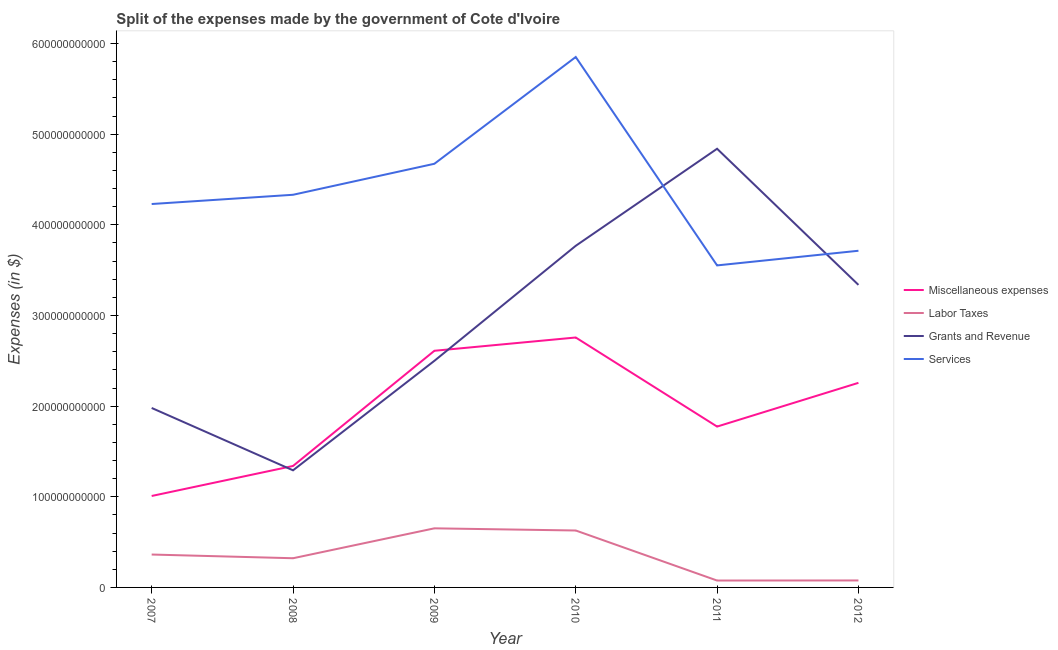How many different coloured lines are there?
Offer a very short reply. 4. Does the line corresponding to amount spent on labor taxes intersect with the line corresponding to amount spent on miscellaneous expenses?
Make the answer very short. No. Is the number of lines equal to the number of legend labels?
Offer a very short reply. Yes. What is the amount spent on miscellaneous expenses in 2011?
Give a very brief answer. 1.77e+11. Across all years, what is the maximum amount spent on labor taxes?
Ensure brevity in your answer.  6.52e+1. Across all years, what is the minimum amount spent on grants and revenue?
Offer a terse response. 1.29e+11. What is the total amount spent on services in the graph?
Provide a succinct answer. 2.64e+12. What is the difference between the amount spent on services in 2011 and that in 2012?
Keep it short and to the point. -1.62e+1. What is the difference between the amount spent on grants and revenue in 2011 and the amount spent on services in 2008?
Give a very brief answer. 5.08e+1. What is the average amount spent on miscellaneous expenses per year?
Your answer should be very brief. 1.96e+11. In the year 2009, what is the difference between the amount spent on services and amount spent on miscellaneous expenses?
Your answer should be compact. 2.06e+11. What is the ratio of the amount spent on labor taxes in 2007 to that in 2010?
Provide a short and direct response. 0.58. What is the difference between the highest and the second highest amount spent on grants and revenue?
Offer a very short reply. 1.07e+11. What is the difference between the highest and the lowest amount spent on labor taxes?
Your response must be concise. 5.76e+1. In how many years, is the amount spent on miscellaneous expenses greater than the average amount spent on miscellaneous expenses taken over all years?
Provide a short and direct response. 3. Is the sum of the amount spent on labor taxes in 2008 and 2010 greater than the maximum amount spent on miscellaneous expenses across all years?
Your answer should be compact. No. Does the amount spent on grants and revenue monotonically increase over the years?
Provide a short and direct response. No. Is the amount spent on grants and revenue strictly greater than the amount spent on labor taxes over the years?
Offer a very short reply. Yes. Is the amount spent on labor taxes strictly less than the amount spent on services over the years?
Give a very brief answer. Yes. How many years are there in the graph?
Your answer should be very brief. 6. What is the difference between two consecutive major ticks on the Y-axis?
Your response must be concise. 1.00e+11. Does the graph contain any zero values?
Your response must be concise. No. Does the graph contain grids?
Make the answer very short. No. How are the legend labels stacked?
Your answer should be very brief. Vertical. What is the title of the graph?
Give a very brief answer. Split of the expenses made by the government of Cote d'Ivoire. Does "Permanent crop land" appear as one of the legend labels in the graph?
Your answer should be compact. No. What is the label or title of the Y-axis?
Make the answer very short. Expenses (in $). What is the Expenses (in $) of Miscellaneous expenses in 2007?
Your answer should be very brief. 1.01e+11. What is the Expenses (in $) in Labor Taxes in 2007?
Your answer should be very brief. 3.63e+1. What is the Expenses (in $) in Grants and Revenue in 2007?
Provide a short and direct response. 1.98e+11. What is the Expenses (in $) of Services in 2007?
Provide a succinct answer. 4.23e+11. What is the Expenses (in $) in Miscellaneous expenses in 2008?
Provide a succinct answer. 1.34e+11. What is the Expenses (in $) of Labor Taxes in 2008?
Ensure brevity in your answer.  3.22e+1. What is the Expenses (in $) in Grants and Revenue in 2008?
Make the answer very short. 1.29e+11. What is the Expenses (in $) in Services in 2008?
Give a very brief answer. 4.33e+11. What is the Expenses (in $) of Miscellaneous expenses in 2009?
Your answer should be compact. 2.61e+11. What is the Expenses (in $) of Labor Taxes in 2009?
Give a very brief answer. 6.52e+1. What is the Expenses (in $) in Grants and Revenue in 2009?
Keep it short and to the point. 2.50e+11. What is the Expenses (in $) of Services in 2009?
Your answer should be very brief. 4.67e+11. What is the Expenses (in $) of Miscellaneous expenses in 2010?
Offer a very short reply. 2.76e+11. What is the Expenses (in $) in Labor Taxes in 2010?
Offer a very short reply. 6.28e+1. What is the Expenses (in $) in Grants and Revenue in 2010?
Offer a very short reply. 3.77e+11. What is the Expenses (in $) in Services in 2010?
Offer a very short reply. 5.85e+11. What is the Expenses (in $) in Miscellaneous expenses in 2011?
Your answer should be compact. 1.77e+11. What is the Expenses (in $) in Labor Taxes in 2011?
Your response must be concise. 7.60e+09. What is the Expenses (in $) of Grants and Revenue in 2011?
Give a very brief answer. 4.84e+11. What is the Expenses (in $) in Services in 2011?
Provide a short and direct response. 3.55e+11. What is the Expenses (in $) of Miscellaneous expenses in 2012?
Give a very brief answer. 2.26e+11. What is the Expenses (in $) in Labor Taxes in 2012?
Provide a short and direct response. 7.70e+09. What is the Expenses (in $) in Grants and Revenue in 2012?
Provide a succinct answer. 3.34e+11. What is the Expenses (in $) of Services in 2012?
Your response must be concise. 3.71e+11. Across all years, what is the maximum Expenses (in $) of Miscellaneous expenses?
Ensure brevity in your answer.  2.76e+11. Across all years, what is the maximum Expenses (in $) in Labor Taxes?
Provide a succinct answer. 6.52e+1. Across all years, what is the maximum Expenses (in $) in Grants and Revenue?
Provide a succinct answer. 4.84e+11. Across all years, what is the maximum Expenses (in $) in Services?
Make the answer very short. 5.85e+11. Across all years, what is the minimum Expenses (in $) of Miscellaneous expenses?
Offer a terse response. 1.01e+11. Across all years, what is the minimum Expenses (in $) in Labor Taxes?
Give a very brief answer. 7.60e+09. Across all years, what is the minimum Expenses (in $) in Grants and Revenue?
Make the answer very short. 1.29e+11. Across all years, what is the minimum Expenses (in $) of Services?
Offer a very short reply. 3.55e+11. What is the total Expenses (in $) of Miscellaneous expenses in the graph?
Your answer should be compact. 1.17e+12. What is the total Expenses (in $) of Labor Taxes in the graph?
Ensure brevity in your answer.  2.12e+11. What is the total Expenses (in $) in Grants and Revenue in the graph?
Provide a succinct answer. 1.77e+12. What is the total Expenses (in $) in Services in the graph?
Your response must be concise. 2.64e+12. What is the difference between the Expenses (in $) in Miscellaneous expenses in 2007 and that in 2008?
Provide a short and direct response. -3.31e+1. What is the difference between the Expenses (in $) of Labor Taxes in 2007 and that in 2008?
Provide a short and direct response. 4.10e+09. What is the difference between the Expenses (in $) of Grants and Revenue in 2007 and that in 2008?
Provide a short and direct response. 6.88e+1. What is the difference between the Expenses (in $) of Services in 2007 and that in 2008?
Provide a succinct answer. -1.02e+1. What is the difference between the Expenses (in $) in Miscellaneous expenses in 2007 and that in 2009?
Offer a very short reply. -1.60e+11. What is the difference between the Expenses (in $) in Labor Taxes in 2007 and that in 2009?
Offer a very short reply. -2.89e+1. What is the difference between the Expenses (in $) of Grants and Revenue in 2007 and that in 2009?
Give a very brief answer. -5.20e+1. What is the difference between the Expenses (in $) of Services in 2007 and that in 2009?
Offer a terse response. -4.44e+1. What is the difference between the Expenses (in $) of Miscellaneous expenses in 2007 and that in 2010?
Offer a terse response. -1.75e+11. What is the difference between the Expenses (in $) in Labor Taxes in 2007 and that in 2010?
Offer a terse response. -2.65e+1. What is the difference between the Expenses (in $) of Grants and Revenue in 2007 and that in 2010?
Make the answer very short. -1.79e+11. What is the difference between the Expenses (in $) of Services in 2007 and that in 2010?
Your answer should be compact. -1.62e+11. What is the difference between the Expenses (in $) of Miscellaneous expenses in 2007 and that in 2011?
Your response must be concise. -7.66e+1. What is the difference between the Expenses (in $) in Labor Taxes in 2007 and that in 2011?
Provide a short and direct response. 2.87e+1. What is the difference between the Expenses (in $) of Grants and Revenue in 2007 and that in 2011?
Offer a very short reply. -2.86e+11. What is the difference between the Expenses (in $) of Services in 2007 and that in 2011?
Make the answer very short. 6.77e+1. What is the difference between the Expenses (in $) in Miscellaneous expenses in 2007 and that in 2012?
Ensure brevity in your answer.  -1.25e+11. What is the difference between the Expenses (in $) in Labor Taxes in 2007 and that in 2012?
Give a very brief answer. 2.86e+1. What is the difference between the Expenses (in $) in Grants and Revenue in 2007 and that in 2012?
Your response must be concise. -1.36e+11. What is the difference between the Expenses (in $) in Services in 2007 and that in 2012?
Your response must be concise. 5.16e+1. What is the difference between the Expenses (in $) of Miscellaneous expenses in 2008 and that in 2009?
Keep it short and to the point. -1.27e+11. What is the difference between the Expenses (in $) in Labor Taxes in 2008 and that in 2009?
Offer a very short reply. -3.30e+1. What is the difference between the Expenses (in $) of Grants and Revenue in 2008 and that in 2009?
Give a very brief answer. -1.21e+11. What is the difference between the Expenses (in $) of Services in 2008 and that in 2009?
Your response must be concise. -3.42e+1. What is the difference between the Expenses (in $) of Miscellaneous expenses in 2008 and that in 2010?
Your answer should be very brief. -1.42e+11. What is the difference between the Expenses (in $) of Labor Taxes in 2008 and that in 2010?
Keep it short and to the point. -3.06e+1. What is the difference between the Expenses (in $) in Grants and Revenue in 2008 and that in 2010?
Ensure brevity in your answer.  -2.48e+11. What is the difference between the Expenses (in $) in Services in 2008 and that in 2010?
Your response must be concise. -1.52e+11. What is the difference between the Expenses (in $) in Miscellaneous expenses in 2008 and that in 2011?
Provide a short and direct response. -4.35e+1. What is the difference between the Expenses (in $) of Labor Taxes in 2008 and that in 2011?
Provide a succinct answer. 2.46e+1. What is the difference between the Expenses (in $) of Grants and Revenue in 2008 and that in 2011?
Keep it short and to the point. -3.55e+11. What is the difference between the Expenses (in $) of Services in 2008 and that in 2011?
Offer a terse response. 7.79e+1. What is the difference between the Expenses (in $) in Miscellaneous expenses in 2008 and that in 2012?
Provide a short and direct response. -9.17e+1. What is the difference between the Expenses (in $) of Labor Taxes in 2008 and that in 2012?
Your answer should be very brief. 2.45e+1. What is the difference between the Expenses (in $) of Grants and Revenue in 2008 and that in 2012?
Ensure brevity in your answer.  -2.05e+11. What is the difference between the Expenses (in $) in Services in 2008 and that in 2012?
Make the answer very short. 6.18e+1. What is the difference between the Expenses (in $) in Miscellaneous expenses in 2009 and that in 2010?
Give a very brief answer. -1.47e+1. What is the difference between the Expenses (in $) in Labor Taxes in 2009 and that in 2010?
Make the answer very short. 2.39e+09. What is the difference between the Expenses (in $) of Grants and Revenue in 2009 and that in 2010?
Offer a terse response. -1.27e+11. What is the difference between the Expenses (in $) of Services in 2009 and that in 2010?
Offer a very short reply. -1.18e+11. What is the difference between the Expenses (in $) in Miscellaneous expenses in 2009 and that in 2011?
Offer a terse response. 8.36e+1. What is the difference between the Expenses (in $) of Labor Taxes in 2009 and that in 2011?
Your answer should be compact. 5.76e+1. What is the difference between the Expenses (in $) in Grants and Revenue in 2009 and that in 2011?
Make the answer very short. -2.34e+11. What is the difference between the Expenses (in $) of Services in 2009 and that in 2011?
Give a very brief answer. 1.12e+11. What is the difference between the Expenses (in $) in Miscellaneous expenses in 2009 and that in 2012?
Ensure brevity in your answer.  3.54e+1. What is the difference between the Expenses (in $) of Labor Taxes in 2009 and that in 2012?
Your answer should be very brief. 5.75e+1. What is the difference between the Expenses (in $) in Grants and Revenue in 2009 and that in 2012?
Your answer should be very brief. -8.38e+1. What is the difference between the Expenses (in $) of Services in 2009 and that in 2012?
Make the answer very short. 9.60e+1. What is the difference between the Expenses (in $) in Miscellaneous expenses in 2010 and that in 2011?
Your answer should be compact. 9.83e+1. What is the difference between the Expenses (in $) in Labor Taxes in 2010 and that in 2011?
Your answer should be very brief. 5.52e+1. What is the difference between the Expenses (in $) of Grants and Revenue in 2010 and that in 2011?
Your answer should be very brief. -1.07e+11. What is the difference between the Expenses (in $) in Services in 2010 and that in 2011?
Offer a very short reply. 2.30e+11. What is the difference between the Expenses (in $) in Miscellaneous expenses in 2010 and that in 2012?
Your answer should be very brief. 5.00e+1. What is the difference between the Expenses (in $) of Labor Taxes in 2010 and that in 2012?
Provide a succinct answer. 5.51e+1. What is the difference between the Expenses (in $) in Grants and Revenue in 2010 and that in 2012?
Your answer should be very brief. 4.31e+1. What is the difference between the Expenses (in $) of Services in 2010 and that in 2012?
Your response must be concise. 2.14e+11. What is the difference between the Expenses (in $) of Miscellaneous expenses in 2011 and that in 2012?
Give a very brief answer. -4.83e+1. What is the difference between the Expenses (in $) of Labor Taxes in 2011 and that in 2012?
Your answer should be very brief. -1.00e+08. What is the difference between the Expenses (in $) of Grants and Revenue in 2011 and that in 2012?
Give a very brief answer. 1.50e+11. What is the difference between the Expenses (in $) in Services in 2011 and that in 2012?
Your answer should be compact. -1.62e+1. What is the difference between the Expenses (in $) in Miscellaneous expenses in 2007 and the Expenses (in $) in Labor Taxes in 2008?
Your answer should be compact. 6.87e+1. What is the difference between the Expenses (in $) in Miscellaneous expenses in 2007 and the Expenses (in $) in Grants and Revenue in 2008?
Give a very brief answer. -2.83e+1. What is the difference between the Expenses (in $) of Miscellaneous expenses in 2007 and the Expenses (in $) of Services in 2008?
Provide a succinct answer. -3.32e+11. What is the difference between the Expenses (in $) in Labor Taxes in 2007 and the Expenses (in $) in Grants and Revenue in 2008?
Offer a terse response. -9.29e+1. What is the difference between the Expenses (in $) in Labor Taxes in 2007 and the Expenses (in $) in Services in 2008?
Offer a very short reply. -3.97e+11. What is the difference between the Expenses (in $) of Grants and Revenue in 2007 and the Expenses (in $) of Services in 2008?
Your answer should be compact. -2.35e+11. What is the difference between the Expenses (in $) of Miscellaneous expenses in 2007 and the Expenses (in $) of Labor Taxes in 2009?
Your response must be concise. 3.57e+1. What is the difference between the Expenses (in $) of Miscellaneous expenses in 2007 and the Expenses (in $) of Grants and Revenue in 2009?
Your response must be concise. -1.49e+11. What is the difference between the Expenses (in $) of Miscellaneous expenses in 2007 and the Expenses (in $) of Services in 2009?
Provide a short and direct response. -3.66e+11. What is the difference between the Expenses (in $) of Labor Taxes in 2007 and the Expenses (in $) of Grants and Revenue in 2009?
Your answer should be very brief. -2.14e+11. What is the difference between the Expenses (in $) in Labor Taxes in 2007 and the Expenses (in $) in Services in 2009?
Give a very brief answer. -4.31e+11. What is the difference between the Expenses (in $) of Grants and Revenue in 2007 and the Expenses (in $) of Services in 2009?
Your answer should be very brief. -2.69e+11. What is the difference between the Expenses (in $) of Miscellaneous expenses in 2007 and the Expenses (in $) of Labor Taxes in 2010?
Provide a succinct answer. 3.81e+1. What is the difference between the Expenses (in $) of Miscellaneous expenses in 2007 and the Expenses (in $) of Grants and Revenue in 2010?
Your answer should be compact. -2.76e+11. What is the difference between the Expenses (in $) in Miscellaneous expenses in 2007 and the Expenses (in $) in Services in 2010?
Provide a succinct answer. -4.84e+11. What is the difference between the Expenses (in $) in Labor Taxes in 2007 and the Expenses (in $) in Grants and Revenue in 2010?
Your response must be concise. -3.41e+11. What is the difference between the Expenses (in $) in Labor Taxes in 2007 and the Expenses (in $) in Services in 2010?
Provide a succinct answer. -5.49e+11. What is the difference between the Expenses (in $) of Grants and Revenue in 2007 and the Expenses (in $) of Services in 2010?
Make the answer very short. -3.87e+11. What is the difference between the Expenses (in $) in Miscellaneous expenses in 2007 and the Expenses (in $) in Labor Taxes in 2011?
Ensure brevity in your answer.  9.33e+1. What is the difference between the Expenses (in $) of Miscellaneous expenses in 2007 and the Expenses (in $) of Grants and Revenue in 2011?
Your answer should be very brief. -3.83e+11. What is the difference between the Expenses (in $) in Miscellaneous expenses in 2007 and the Expenses (in $) in Services in 2011?
Your response must be concise. -2.54e+11. What is the difference between the Expenses (in $) of Labor Taxes in 2007 and the Expenses (in $) of Grants and Revenue in 2011?
Offer a terse response. -4.48e+11. What is the difference between the Expenses (in $) in Labor Taxes in 2007 and the Expenses (in $) in Services in 2011?
Provide a succinct answer. -3.19e+11. What is the difference between the Expenses (in $) in Grants and Revenue in 2007 and the Expenses (in $) in Services in 2011?
Ensure brevity in your answer.  -1.57e+11. What is the difference between the Expenses (in $) in Miscellaneous expenses in 2007 and the Expenses (in $) in Labor Taxes in 2012?
Provide a succinct answer. 9.32e+1. What is the difference between the Expenses (in $) in Miscellaneous expenses in 2007 and the Expenses (in $) in Grants and Revenue in 2012?
Your response must be concise. -2.33e+11. What is the difference between the Expenses (in $) in Miscellaneous expenses in 2007 and the Expenses (in $) in Services in 2012?
Keep it short and to the point. -2.71e+11. What is the difference between the Expenses (in $) in Labor Taxes in 2007 and the Expenses (in $) in Grants and Revenue in 2012?
Your answer should be very brief. -2.97e+11. What is the difference between the Expenses (in $) of Labor Taxes in 2007 and the Expenses (in $) of Services in 2012?
Your answer should be very brief. -3.35e+11. What is the difference between the Expenses (in $) in Grants and Revenue in 2007 and the Expenses (in $) in Services in 2012?
Your answer should be very brief. -1.73e+11. What is the difference between the Expenses (in $) of Miscellaneous expenses in 2008 and the Expenses (in $) of Labor Taxes in 2009?
Provide a succinct answer. 6.88e+1. What is the difference between the Expenses (in $) in Miscellaneous expenses in 2008 and the Expenses (in $) in Grants and Revenue in 2009?
Provide a succinct answer. -1.16e+11. What is the difference between the Expenses (in $) in Miscellaneous expenses in 2008 and the Expenses (in $) in Services in 2009?
Ensure brevity in your answer.  -3.33e+11. What is the difference between the Expenses (in $) of Labor Taxes in 2008 and the Expenses (in $) of Grants and Revenue in 2009?
Provide a succinct answer. -2.18e+11. What is the difference between the Expenses (in $) of Labor Taxes in 2008 and the Expenses (in $) of Services in 2009?
Offer a very short reply. -4.35e+11. What is the difference between the Expenses (in $) of Grants and Revenue in 2008 and the Expenses (in $) of Services in 2009?
Provide a succinct answer. -3.38e+11. What is the difference between the Expenses (in $) in Miscellaneous expenses in 2008 and the Expenses (in $) in Labor Taxes in 2010?
Provide a succinct answer. 7.12e+1. What is the difference between the Expenses (in $) in Miscellaneous expenses in 2008 and the Expenses (in $) in Grants and Revenue in 2010?
Offer a very short reply. -2.43e+11. What is the difference between the Expenses (in $) in Miscellaneous expenses in 2008 and the Expenses (in $) in Services in 2010?
Provide a short and direct response. -4.51e+11. What is the difference between the Expenses (in $) of Labor Taxes in 2008 and the Expenses (in $) of Grants and Revenue in 2010?
Give a very brief answer. -3.45e+11. What is the difference between the Expenses (in $) in Labor Taxes in 2008 and the Expenses (in $) in Services in 2010?
Offer a terse response. -5.53e+11. What is the difference between the Expenses (in $) in Grants and Revenue in 2008 and the Expenses (in $) in Services in 2010?
Offer a terse response. -4.56e+11. What is the difference between the Expenses (in $) in Miscellaneous expenses in 2008 and the Expenses (in $) in Labor Taxes in 2011?
Your answer should be very brief. 1.26e+11. What is the difference between the Expenses (in $) in Miscellaneous expenses in 2008 and the Expenses (in $) in Grants and Revenue in 2011?
Your response must be concise. -3.50e+11. What is the difference between the Expenses (in $) of Miscellaneous expenses in 2008 and the Expenses (in $) of Services in 2011?
Ensure brevity in your answer.  -2.21e+11. What is the difference between the Expenses (in $) of Labor Taxes in 2008 and the Expenses (in $) of Grants and Revenue in 2011?
Your response must be concise. -4.52e+11. What is the difference between the Expenses (in $) in Labor Taxes in 2008 and the Expenses (in $) in Services in 2011?
Give a very brief answer. -3.23e+11. What is the difference between the Expenses (in $) in Grants and Revenue in 2008 and the Expenses (in $) in Services in 2011?
Your answer should be very brief. -2.26e+11. What is the difference between the Expenses (in $) in Miscellaneous expenses in 2008 and the Expenses (in $) in Labor Taxes in 2012?
Ensure brevity in your answer.  1.26e+11. What is the difference between the Expenses (in $) in Miscellaneous expenses in 2008 and the Expenses (in $) in Grants and Revenue in 2012?
Your response must be concise. -2.00e+11. What is the difference between the Expenses (in $) of Miscellaneous expenses in 2008 and the Expenses (in $) of Services in 2012?
Keep it short and to the point. -2.37e+11. What is the difference between the Expenses (in $) in Labor Taxes in 2008 and the Expenses (in $) in Grants and Revenue in 2012?
Offer a terse response. -3.02e+11. What is the difference between the Expenses (in $) of Labor Taxes in 2008 and the Expenses (in $) of Services in 2012?
Make the answer very short. -3.39e+11. What is the difference between the Expenses (in $) in Grants and Revenue in 2008 and the Expenses (in $) in Services in 2012?
Offer a terse response. -2.42e+11. What is the difference between the Expenses (in $) in Miscellaneous expenses in 2009 and the Expenses (in $) in Labor Taxes in 2010?
Keep it short and to the point. 1.98e+11. What is the difference between the Expenses (in $) of Miscellaneous expenses in 2009 and the Expenses (in $) of Grants and Revenue in 2010?
Ensure brevity in your answer.  -1.16e+11. What is the difference between the Expenses (in $) in Miscellaneous expenses in 2009 and the Expenses (in $) in Services in 2010?
Ensure brevity in your answer.  -3.24e+11. What is the difference between the Expenses (in $) of Labor Taxes in 2009 and the Expenses (in $) of Grants and Revenue in 2010?
Your answer should be very brief. -3.12e+11. What is the difference between the Expenses (in $) of Labor Taxes in 2009 and the Expenses (in $) of Services in 2010?
Your answer should be very brief. -5.20e+11. What is the difference between the Expenses (in $) of Grants and Revenue in 2009 and the Expenses (in $) of Services in 2010?
Offer a terse response. -3.35e+11. What is the difference between the Expenses (in $) in Miscellaneous expenses in 2009 and the Expenses (in $) in Labor Taxes in 2011?
Ensure brevity in your answer.  2.53e+11. What is the difference between the Expenses (in $) of Miscellaneous expenses in 2009 and the Expenses (in $) of Grants and Revenue in 2011?
Offer a very short reply. -2.23e+11. What is the difference between the Expenses (in $) in Miscellaneous expenses in 2009 and the Expenses (in $) in Services in 2011?
Your answer should be compact. -9.42e+1. What is the difference between the Expenses (in $) in Labor Taxes in 2009 and the Expenses (in $) in Grants and Revenue in 2011?
Provide a short and direct response. -4.19e+11. What is the difference between the Expenses (in $) in Labor Taxes in 2009 and the Expenses (in $) in Services in 2011?
Your answer should be very brief. -2.90e+11. What is the difference between the Expenses (in $) of Grants and Revenue in 2009 and the Expenses (in $) of Services in 2011?
Your answer should be very brief. -1.05e+11. What is the difference between the Expenses (in $) in Miscellaneous expenses in 2009 and the Expenses (in $) in Labor Taxes in 2012?
Your answer should be very brief. 2.53e+11. What is the difference between the Expenses (in $) of Miscellaneous expenses in 2009 and the Expenses (in $) of Grants and Revenue in 2012?
Offer a terse response. -7.27e+1. What is the difference between the Expenses (in $) in Miscellaneous expenses in 2009 and the Expenses (in $) in Services in 2012?
Provide a short and direct response. -1.10e+11. What is the difference between the Expenses (in $) in Labor Taxes in 2009 and the Expenses (in $) in Grants and Revenue in 2012?
Make the answer very short. -2.69e+11. What is the difference between the Expenses (in $) in Labor Taxes in 2009 and the Expenses (in $) in Services in 2012?
Your response must be concise. -3.06e+11. What is the difference between the Expenses (in $) of Grants and Revenue in 2009 and the Expenses (in $) of Services in 2012?
Your answer should be compact. -1.21e+11. What is the difference between the Expenses (in $) in Miscellaneous expenses in 2010 and the Expenses (in $) in Labor Taxes in 2011?
Provide a short and direct response. 2.68e+11. What is the difference between the Expenses (in $) of Miscellaneous expenses in 2010 and the Expenses (in $) of Grants and Revenue in 2011?
Provide a succinct answer. -2.08e+11. What is the difference between the Expenses (in $) in Miscellaneous expenses in 2010 and the Expenses (in $) in Services in 2011?
Your answer should be compact. -7.95e+1. What is the difference between the Expenses (in $) in Labor Taxes in 2010 and the Expenses (in $) in Grants and Revenue in 2011?
Your answer should be very brief. -4.21e+11. What is the difference between the Expenses (in $) of Labor Taxes in 2010 and the Expenses (in $) of Services in 2011?
Give a very brief answer. -2.92e+11. What is the difference between the Expenses (in $) of Grants and Revenue in 2010 and the Expenses (in $) of Services in 2011?
Ensure brevity in your answer.  2.16e+1. What is the difference between the Expenses (in $) in Miscellaneous expenses in 2010 and the Expenses (in $) in Labor Taxes in 2012?
Offer a very short reply. 2.68e+11. What is the difference between the Expenses (in $) of Miscellaneous expenses in 2010 and the Expenses (in $) of Grants and Revenue in 2012?
Provide a succinct answer. -5.80e+1. What is the difference between the Expenses (in $) of Miscellaneous expenses in 2010 and the Expenses (in $) of Services in 2012?
Provide a succinct answer. -9.57e+1. What is the difference between the Expenses (in $) of Labor Taxes in 2010 and the Expenses (in $) of Grants and Revenue in 2012?
Provide a short and direct response. -2.71e+11. What is the difference between the Expenses (in $) of Labor Taxes in 2010 and the Expenses (in $) of Services in 2012?
Provide a short and direct response. -3.09e+11. What is the difference between the Expenses (in $) of Grants and Revenue in 2010 and the Expenses (in $) of Services in 2012?
Give a very brief answer. 5.47e+09. What is the difference between the Expenses (in $) of Miscellaneous expenses in 2011 and the Expenses (in $) of Labor Taxes in 2012?
Make the answer very short. 1.70e+11. What is the difference between the Expenses (in $) in Miscellaneous expenses in 2011 and the Expenses (in $) in Grants and Revenue in 2012?
Your answer should be very brief. -1.56e+11. What is the difference between the Expenses (in $) in Miscellaneous expenses in 2011 and the Expenses (in $) in Services in 2012?
Offer a very short reply. -1.94e+11. What is the difference between the Expenses (in $) in Labor Taxes in 2011 and the Expenses (in $) in Grants and Revenue in 2012?
Give a very brief answer. -3.26e+11. What is the difference between the Expenses (in $) of Labor Taxes in 2011 and the Expenses (in $) of Services in 2012?
Provide a short and direct response. -3.64e+11. What is the difference between the Expenses (in $) in Grants and Revenue in 2011 and the Expenses (in $) in Services in 2012?
Your answer should be very brief. 1.13e+11. What is the average Expenses (in $) in Miscellaneous expenses per year?
Make the answer very short. 1.96e+11. What is the average Expenses (in $) of Labor Taxes per year?
Offer a very short reply. 3.53e+1. What is the average Expenses (in $) in Grants and Revenue per year?
Offer a terse response. 2.95e+11. What is the average Expenses (in $) of Services per year?
Offer a very short reply. 4.39e+11. In the year 2007, what is the difference between the Expenses (in $) of Miscellaneous expenses and Expenses (in $) of Labor Taxes?
Provide a short and direct response. 6.46e+1. In the year 2007, what is the difference between the Expenses (in $) of Miscellaneous expenses and Expenses (in $) of Grants and Revenue?
Provide a succinct answer. -9.71e+1. In the year 2007, what is the difference between the Expenses (in $) in Miscellaneous expenses and Expenses (in $) in Services?
Provide a short and direct response. -3.22e+11. In the year 2007, what is the difference between the Expenses (in $) of Labor Taxes and Expenses (in $) of Grants and Revenue?
Make the answer very short. -1.62e+11. In the year 2007, what is the difference between the Expenses (in $) in Labor Taxes and Expenses (in $) in Services?
Your answer should be very brief. -3.87e+11. In the year 2007, what is the difference between the Expenses (in $) of Grants and Revenue and Expenses (in $) of Services?
Your answer should be compact. -2.25e+11. In the year 2008, what is the difference between the Expenses (in $) of Miscellaneous expenses and Expenses (in $) of Labor Taxes?
Provide a succinct answer. 1.02e+11. In the year 2008, what is the difference between the Expenses (in $) of Miscellaneous expenses and Expenses (in $) of Grants and Revenue?
Provide a succinct answer. 4.80e+09. In the year 2008, what is the difference between the Expenses (in $) in Miscellaneous expenses and Expenses (in $) in Services?
Ensure brevity in your answer.  -2.99e+11. In the year 2008, what is the difference between the Expenses (in $) in Labor Taxes and Expenses (in $) in Grants and Revenue?
Give a very brief answer. -9.70e+1. In the year 2008, what is the difference between the Expenses (in $) in Labor Taxes and Expenses (in $) in Services?
Ensure brevity in your answer.  -4.01e+11. In the year 2008, what is the difference between the Expenses (in $) in Grants and Revenue and Expenses (in $) in Services?
Your answer should be very brief. -3.04e+11. In the year 2009, what is the difference between the Expenses (in $) of Miscellaneous expenses and Expenses (in $) of Labor Taxes?
Offer a very short reply. 1.96e+11. In the year 2009, what is the difference between the Expenses (in $) of Miscellaneous expenses and Expenses (in $) of Grants and Revenue?
Provide a short and direct response. 1.11e+1. In the year 2009, what is the difference between the Expenses (in $) of Miscellaneous expenses and Expenses (in $) of Services?
Offer a terse response. -2.06e+11. In the year 2009, what is the difference between the Expenses (in $) in Labor Taxes and Expenses (in $) in Grants and Revenue?
Ensure brevity in your answer.  -1.85e+11. In the year 2009, what is the difference between the Expenses (in $) of Labor Taxes and Expenses (in $) of Services?
Offer a very short reply. -4.02e+11. In the year 2009, what is the difference between the Expenses (in $) of Grants and Revenue and Expenses (in $) of Services?
Give a very brief answer. -2.17e+11. In the year 2010, what is the difference between the Expenses (in $) of Miscellaneous expenses and Expenses (in $) of Labor Taxes?
Your answer should be very brief. 2.13e+11. In the year 2010, what is the difference between the Expenses (in $) of Miscellaneous expenses and Expenses (in $) of Grants and Revenue?
Give a very brief answer. -1.01e+11. In the year 2010, what is the difference between the Expenses (in $) of Miscellaneous expenses and Expenses (in $) of Services?
Your response must be concise. -3.09e+11. In the year 2010, what is the difference between the Expenses (in $) in Labor Taxes and Expenses (in $) in Grants and Revenue?
Your answer should be compact. -3.14e+11. In the year 2010, what is the difference between the Expenses (in $) of Labor Taxes and Expenses (in $) of Services?
Ensure brevity in your answer.  -5.22e+11. In the year 2010, what is the difference between the Expenses (in $) of Grants and Revenue and Expenses (in $) of Services?
Offer a very short reply. -2.08e+11. In the year 2011, what is the difference between the Expenses (in $) of Miscellaneous expenses and Expenses (in $) of Labor Taxes?
Your response must be concise. 1.70e+11. In the year 2011, what is the difference between the Expenses (in $) of Miscellaneous expenses and Expenses (in $) of Grants and Revenue?
Give a very brief answer. -3.07e+11. In the year 2011, what is the difference between the Expenses (in $) in Miscellaneous expenses and Expenses (in $) in Services?
Offer a very short reply. -1.78e+11. In the year 2011, what is the difference between the Expenses (in $) in Labor Taxes and Expenses (in $) in Grants and Revenue?
Offer a very short reply. -4.76e+11. In the year 2011, what is the difference between the Expenses (in $) in Labor Taxes and Expenses (in $) in Services?
Ensure brevity in your answer.  -3.48e+11. In the year 2011, what is the difference between the Expenses (in $) in Grants and Revenue and Expenses (in $) in Services?
Give a very brief answer. 1.29e+11. In the year 2012, what is the difference between the Expenses (in $) in Miscellaneous expenses and Expenses (in $) in Labor Taxes?
Offer a terse response. 2.18e+11. In the year 2012, what is the difference between the Expenses (in $) in Miscellaneous expenses and Expenses (in $) in Grants and Revenue?
Keep it short and to the point. -1.08e+11. In the year 2012, what is the difference between the Expenses (in $) of Miscellaneous expenses and Expenses (in $) of Services?
Give a very brief answer. -1.46e+11. In the year 2012, what is the difference between the Expenses (in $) of Labor Taxes and Expenses (in $) of Grants and Revenue?
Provide a succinct answer. -3.26e+11. In the year 2012, what is the difference between the Expenses (in $) of Labor Taxes and Expenses (in $) of Services?
Give a very brief answer. -3.64e+11. In the year 2012, what is the difference between the Expenses (in $) of Grants and Revenue and Expenses (in $) of Services?
Provide a short and direct response. -3.77e+1. What is the ratio of the Expenses (in $) in Miscellaneous expenses in 2007 to that in 2008?
Ensure brevity in your answer.  0.75. What is the ratio of the Expenses (in $) of Labor Taxes in 2007 to that in 2008?
Ensure brevity in your answer.  1.13. What is the ratio of the Expenses (in $) of Grants and Revenue in 2007 to that in 2008?
Give a very brief answer. 1.53. What is the ratio of the Expenses (in $) of Services in 2007 to that in 2008?
Provide a short and direct response. 0.98. What is the ratio of the Expenses (in $) in Miscellaneous expenses in 2007 to that in 2009?
Your answer should be very brief. 0.39. What is the ratio of the Expenses (in $) of Labor Taxes in 2007 to that in 2009?
Keep it short and to the point. 0.56. What is the ratio of the Expenses (in $) in Grants and Revenue in 2007 to that in 2009?
Keep it short and to the point. 0.79. What is the ratio of the Expenses (in $) of Services in 2007 to that in 2009?
Ensure brevity in your answer.  0.91. What is the ratio of the Expenses (in $) of Miscellaneous expenses in 2007 to that in 2010?
Provide a succinct answer. 0.37. What is the ratio of the Expenses (in $) in Labor Taxes in 2007 to that in 2010?
Make the answer very short. 0.58. What is the ratio of the Expenses (in $) in Grants and Revenue in 2007 to that in 2010?
Ensure brevity in your answer.  0.53. What is the ratio of the Expenses (in $) of Services in 2007 to that in 2010?
Your answer should be very brief. 0.72. What is the ratio of the Expenses (in $) in Miscellaneous expenses in 2007 to that in 2011?
Provide a succinct answer. 0.57. What is the ratio of the Expenses (in $) in Labor Taxes in 2007 to that in 2011?
Your answer should be compact. 4.78. What is the ratio of the Expenses (in $) of Grants and Revenue in 2007 to that in 2011?
Ensure brevity in your answer.  0.41. What is the ratio of the Expenses (in $) of Services in 2007 to that in 2011?
Your answer should be very brief. 1.19. What is the ratio of the Expenses (in $) in Miscellaneous expenses in 2007 to that in 2012?
Your answer should be very brief. 0.45. What is the ratio of the Expenses (in $) in Labor Taxes in 2007 to that in 2012?
Your answer should be very brief. 4.71. What is the ratio of the Expenses (in $) of Grants and Revenue in 2007 to that in 2012?
Offer a very short reply. 0.59. What is the ratio of the Expenses (in $) of Services in 2007 to that in 2012?
Offer a terse response. 1.14. What is the ratio of the Expenses (in $) of Miscellaneous expenses in 2008 to that in 2009?
Provide a succinct answer. 0.51. What is the ratio of the Expenses (in $) of Labor Taxes in 2008 to that in 2009?
Provide a short and direct response. 0.49. What is the ratio of the Expenses (in $) in Grants and Revenue in 2008 to that in 2009?
Ensure brevity in your answer.  0.52. What is the ratio of the Expenses (in $) in Services in 2008 to that in 2009?
Your response must be concise. 0.93. What is the ratio of the Expenses (in $) of Miscellaneous expenses in 2008 to that in 2010?
Your response must be concise. 0.49. What is the ratio of the Expenses (in $) of Labor Taxes in 2008 to that in 2010?
Your response must be concise. 0.51. What is the ratio of the Expenses (in $) in Grants and Revenue in 2008 to that in 2010?
Give a very brief answer. 0.34. What is the ratio of the Expenses (in $) in Services in 2008 to that in 2010?
Your answer should be compact. 0.74. What is the ratio of the Expenses (in $) of Miscellaneous expenses in 2008 to that in 2011?
Your response must be concise. 0.76. What is the ratio of the Expenses (in $) of Labor Taxes in 2008 to that in 2011?
Your answer should be very brief. 4.24. What is the ratio of the Expenses (in $) of Grants and Revenue in 2008 to that in 2011?
Provide a succinct answer. 0.27. What is the ratio of the Expenses (in $) of Services in 2008 to that in 2011?
Your answer should be very brief. 1.22. What is the ratio of the Expenses (in $) of Miscellaneous expenses in 2008 to that in 2012?
Make the answer very short. 0.59. What is the ratio of the Expenses (in $) in Labor Taxes in 2008 to that in 2012?
Provide a short and direct response. 4.18. What is the ratio of the Expenses (in $) of Grants and Revenue in 2008 to that in 2012?
Provide a short and direct response. 0.39. What is the ratio of the Expenses (in $) of Services in 2008 to that in 2012?
Offer a very short reply. 1.17. What is the ratio of the Expenses (in $) in Miscellaneous expenses in 2009 to that in 2010?
Give a very brief answer. 0.95. What is the ratio of the Expenses (in $) in Labor Taxes in 2009 to that in 2010?
Keep it short and to the point. 1.04. What is the ratio of the Expenses (in $) of Grants and Revenue in 2009 to that in 2010?
Make the answer very short. 0.66. What is the ratio of the Expenses (in $) of Services in 2009 to that in 2010?
Make the answer very short. 0.8. What is the ratio of the Expenses (in $) of Miscellaneous expenses in 2009 to that in 2011?
Your answer should be very brief. 1.47. What is the ratio of the Expenses (in $) of Labor Taxes in 2009 to that in 2011?
Keep it short and to the point. 8.58. What is the ratio of the Expenses (in $) of Grants and Revenue in 2009 to that in 2011?
Provide a succinct answer. 0.52. What is the ratio of the Expenses (in $) of Services in 2009 to that in 2011?
Offer a terse response. 1.32. What is the ratio of the Expenses (in $) in Miscellaneous expenses in 2009 to that in 2012?
Give a very brief answer. 1.16. What is the ratio of the Expenses (in $) in Labor Taxes in 2009 to that in 2012?
Provide a short and direct response. 8.47. What is the ratio of the Expenses (in $) of Grants and Revenue in 2009 to that in 2012?
Make the answer very short. 0.75. What is the ratio of the Expenses (in $) in Services in 2009 to that in 2012?
Make the answer very short. 1.26. What is the ratio of the Expenses (in $) of Miscellaneous expenses in 2010 to that in 2011?
Give a very brief answer. 1.55. What is the ratio of the Expenses (in $) of Labor Taxes in 2010 to that in 2011?
Provide a succinct answer. 8.26. What is the ratio of the Expenses (in $) in Grants and Revenue in 2010 to that in 2011?
Provide a short and direct response. 0.78. What is the ratio of the Expenses (in $) of Services in 2010 to that in 2011?
Your response must be concise. 1.65. What is the ratio of the Expenses (in $) in Miscellaneous expenses in 2010 to that in 2012?
Your response must be concise. 1.22. What is the ratio of the Expenses (in $) of Labor Taxes in 2010 to that in 2012?
Your answer should be compact. 8.16. What is the ratio of the Expenses (in $) in Grants and Revenue in 2010 to that in 2012?
Give a very brief answer. 1.13. What is the ratio of the Expenses (in $) of Services in 2010 to that in 2012?
Provide a succinct answer. 1.58. What is the ratio of the Expenses (in $) of Miscellaneous expenses in 2011 to that in 2012?
Ensure brevity in your answer.  0.79. What is the ratio of the Expenses (in $) in Labor Taxes in 2011 to that in 2012?
Make the answer very short. 0.99. What is the ratio of the Expenses (in $) in Grants and Revenue in 2011 to that in 2012?
Your answer should be compact. 1.45. What is the ratio of the Expenses (in $) of Services in 2011 to that in 2012?
Offer a terse response. 0.96. What is the difference between the highest and the second highest Expenses (in $) of Miscellaneous expenses?
Ensure brevity in your answer.  1.47e+1. What is the difference between the highest and the second highest Expenses (in $) of Labor Taxes?
Your answer should be compact. 2.39e+09. What is the difference between the highest and the second highest Expenses (in $) in Grants and Revenue?
Your answer should be very brief. 1.07e+11. What is the difference between the highest and the second highest Expenses (in $) of Services?
Give a very brief answer. 1.18e+11. What is the difference between the highest and the lowest Expenses (in $) of Miscellaneous expenses?
Your response must be concise. 1.75e+11. What is the difference between the highest and the lowest Expenses (in $) in Labor Taxes?
Your response must be concise. 5.76e+1. What is the difference between the highest and the lowest Expenses (in $) of Grants and Revenue?
Your answer should be compact. 3.55e+11. What is the difference between the highest and the lowest Expenses (in $) of Services?
Provide a short and direct response. 2.30e+11. 